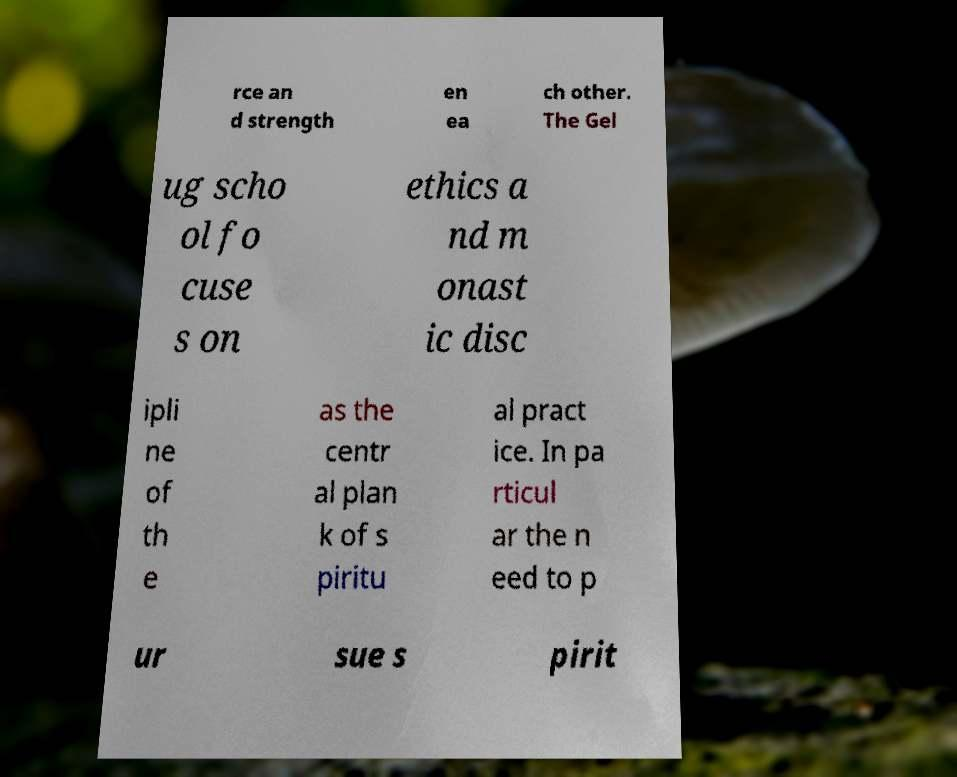There's text embedded in this image that I need extracted. Can you transcribe it verbatim? rce an d strength en ea ch other. The Gel ug scho ol fo cuse s on ethics a nd m onast ic disc ipli ne of th e as the centr al plan k of s piritu al pract ice. In pa rticul ar the n eed to p ur sue s pirit 